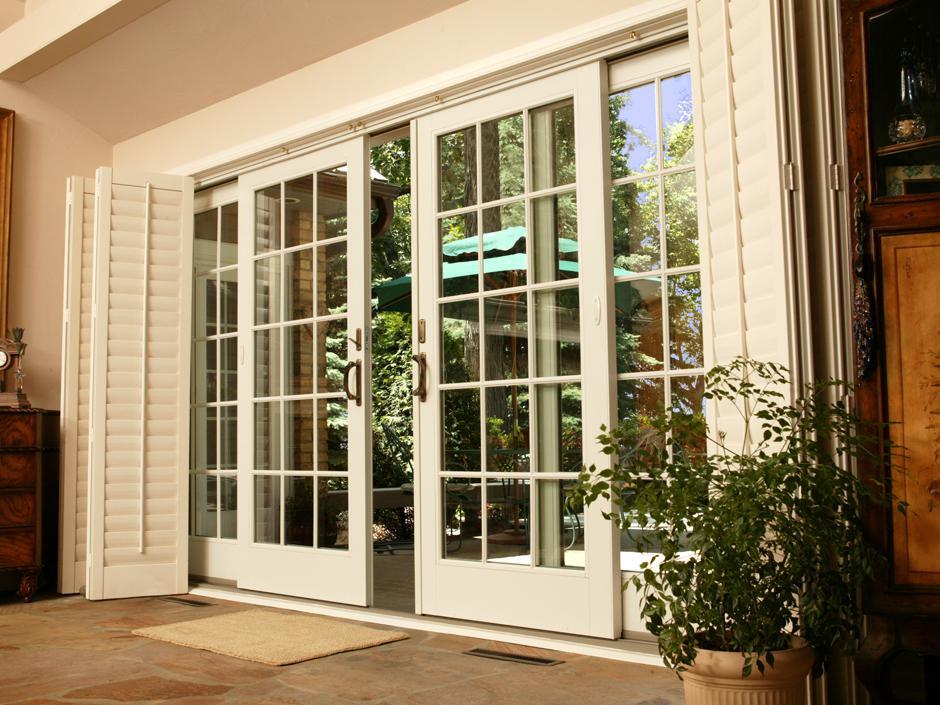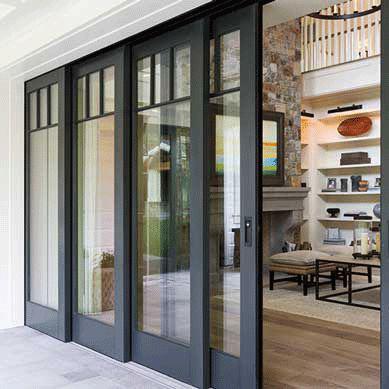The first image is the image on the left, the second image is the image on the right. Considering the images on both sides, is "There is a potted plant in the image on the left." valid? Answer yes or no. Yes. 